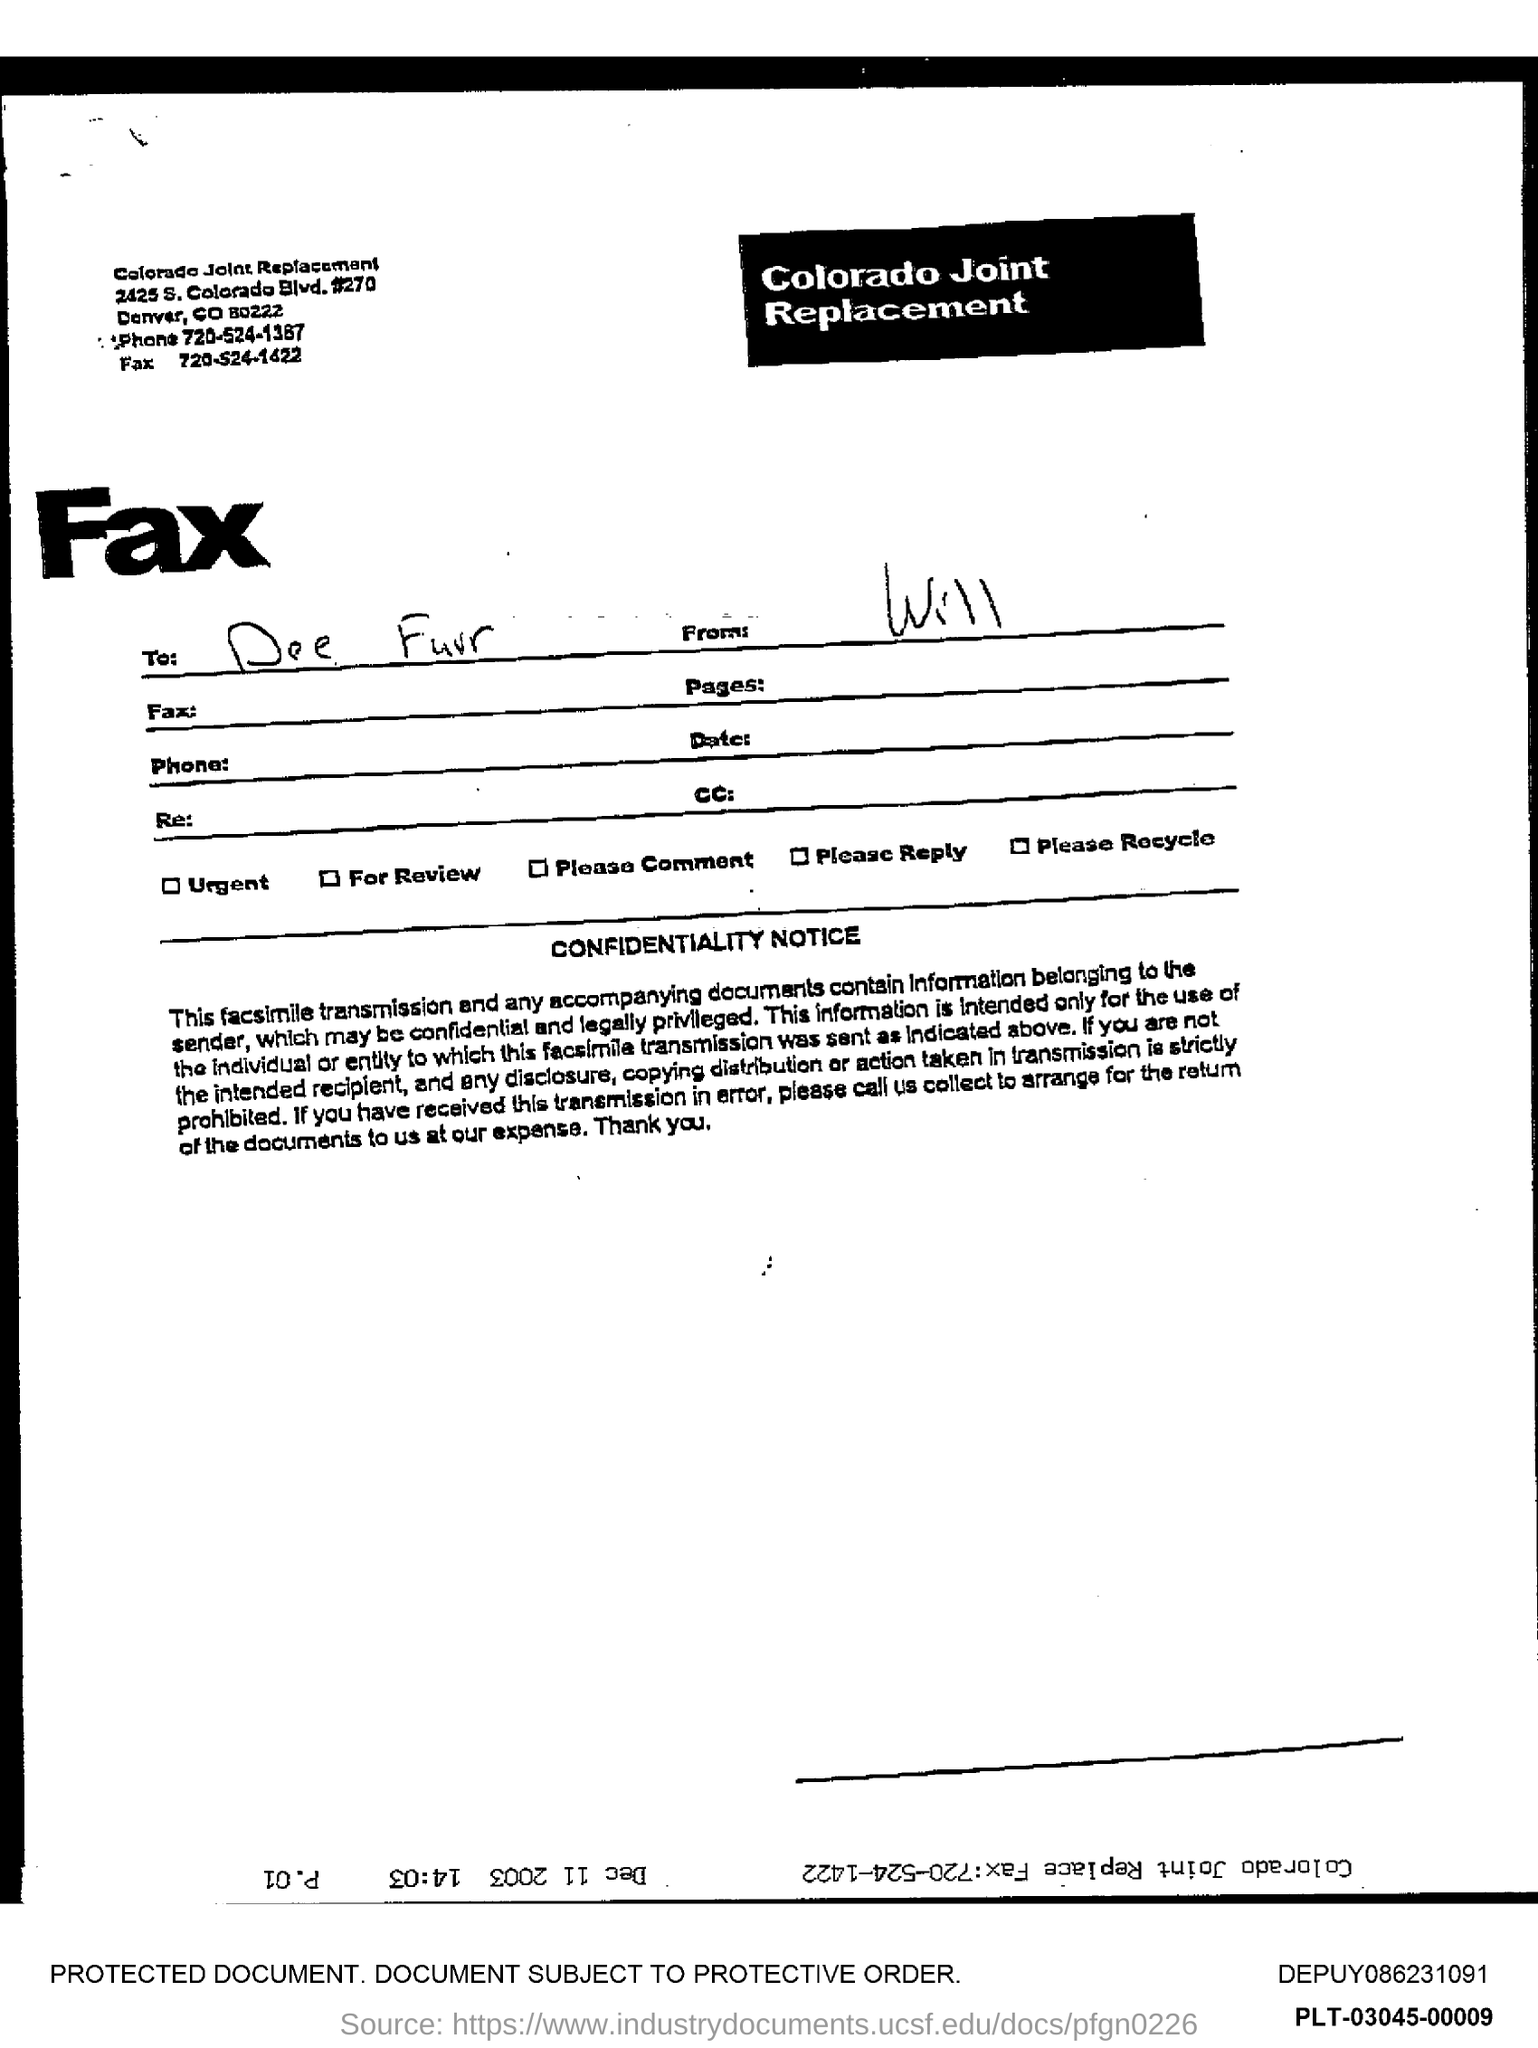Highlight a few significant elements in this photo. The phone number mentioned in the document is 720-524-1387. 